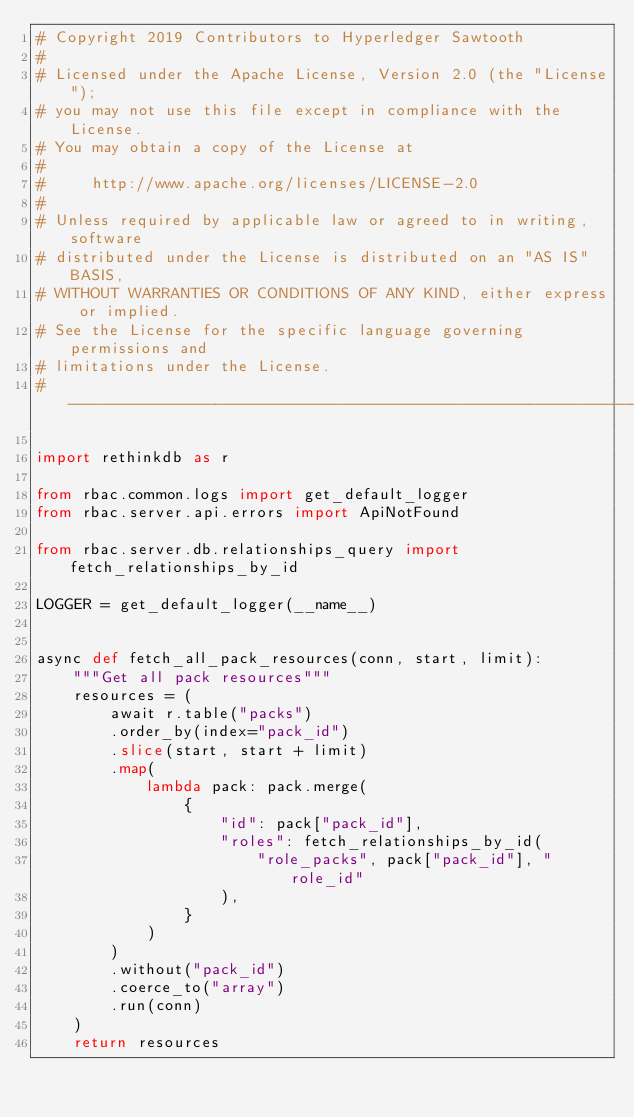Convert code to text. <code><loc_0><loc_0><loc_500><loc_500><_Python_># Copyright 2019 Contributors to Hyperledger Sawtooth
#
# Licensed under the Apache License, Version 2.0 (the "License");
# you may not use this file except in compliance with the License.
# You may obtain a copy of the License at
#
#     http://www.apache.org/licenses/LICENSE-2.0
#
# Unless required by applicable law or agreed to in writing, software
# distributed under the License is distributed on an "AS IS" BASIS,
# WITHOUT WARRANTIES OR CONDITIONS OF ANY KIND, either express or implied.
# See the License for the specific language governing permissions and
# limitations under the License.
# ------------------------------------------------------------------------------

import rethinkdb as r

from rbac.common.logs import get_default_logger
from rbac.server.api.errors import ApiNotFound

from rbac.server.db.relationships_query import fetch_relationships_by_id

LOGGER = get_default_logger(__name__)


async def fetch_all_pack_resources(conn, start, limit):
    """Get all pack resources"""
    resources = (
        await r.table("packs")
        .order_by(index="pack_id")
        .slice(start, start + limit)
        .map(
            lambda pack: pack.merge(
                {
                    "id": pack["pack_id"],
                    "roles": fetch_relationships_by_id(
                        "role_packs", pack["pack_id"], "role_id"
                    ),
                }
            )
        )
        .without("pack_id")
        .coerce_to("array")
        .run(conn)
    )
    return resources

</code> 